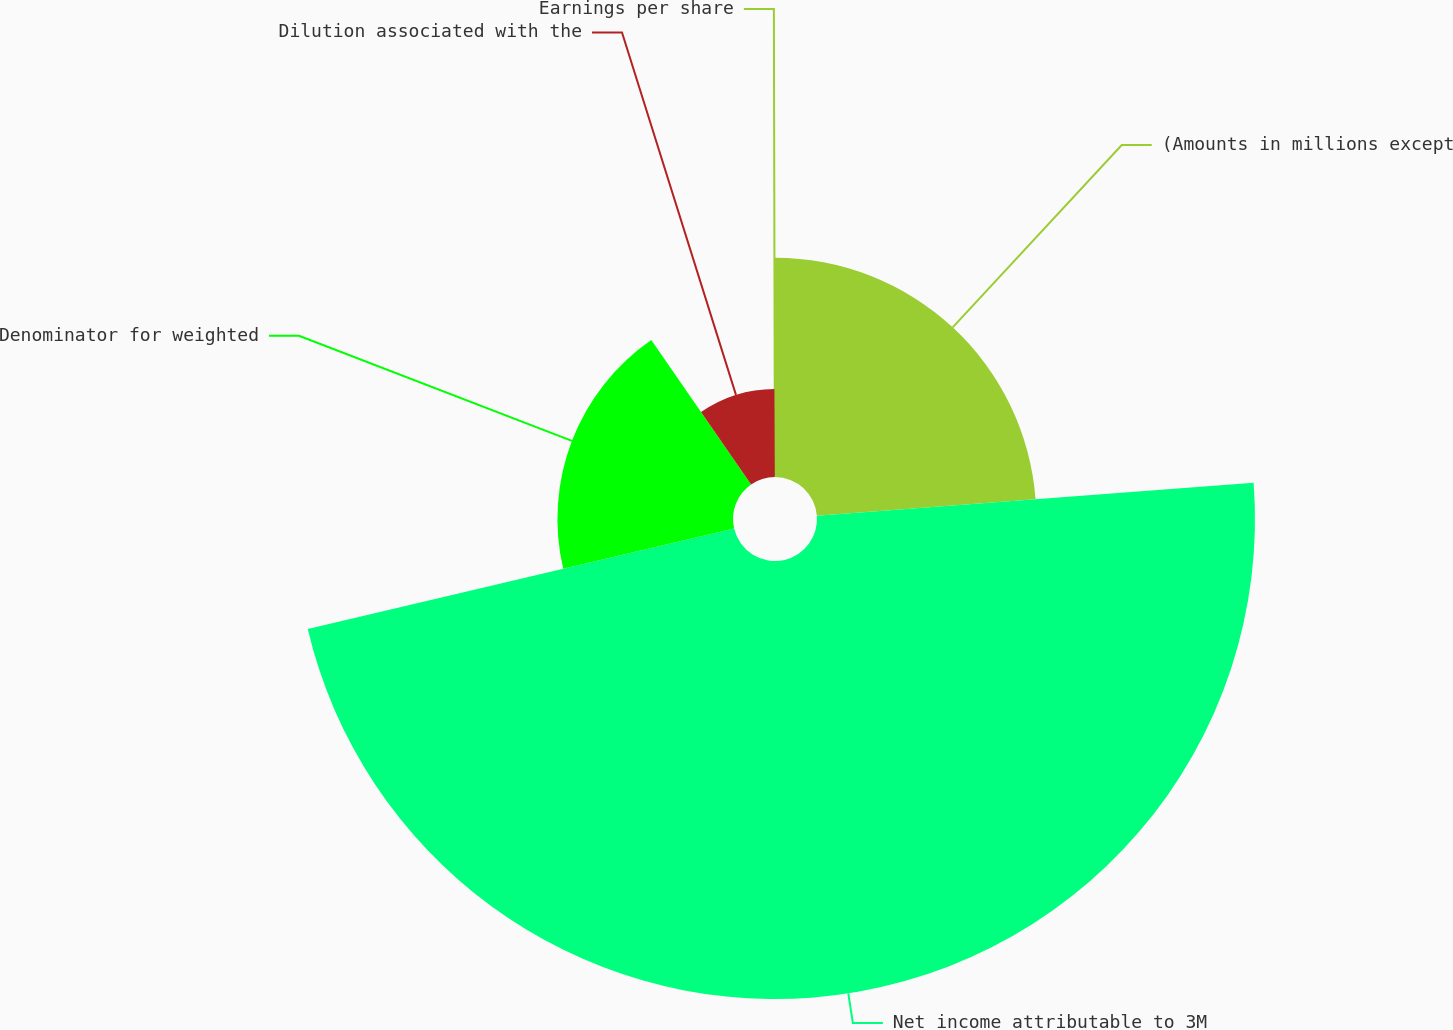Convert chart to OTSL. <chart><loc_0><loc_0><loc_500><loc_500><pie_chart><fcel>(Amounts in millions except<fcel>Net income attributable to 3M<fcel>Denominator for weighted<fcel>Dilution associated with the<fcel>Earnings per share<nl><fcel>23.8%<fcel>47.53%<fcel>19.05%<fcel>9.56%<fcel>0.07%<nl></chart> 